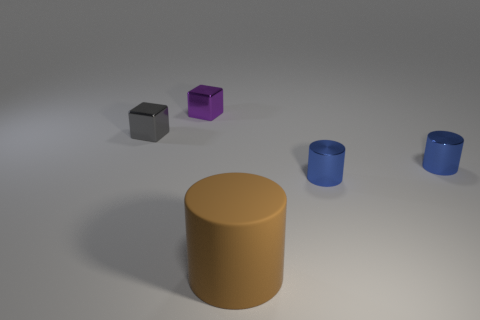Add 2 cylinders. How many objects exist? 7 Subtract all blocks. How many objects are left? 3 Add 3 big brown rubber things. How many big brown rubber things are left? 4 Add 5 brown balls. How many brown balls exist? 5 Subtract 0 cyan cylinders. How many objects are left? 5 Subtract all small purple metal cubes. Subtract all large objects. How many objects are left? 3 